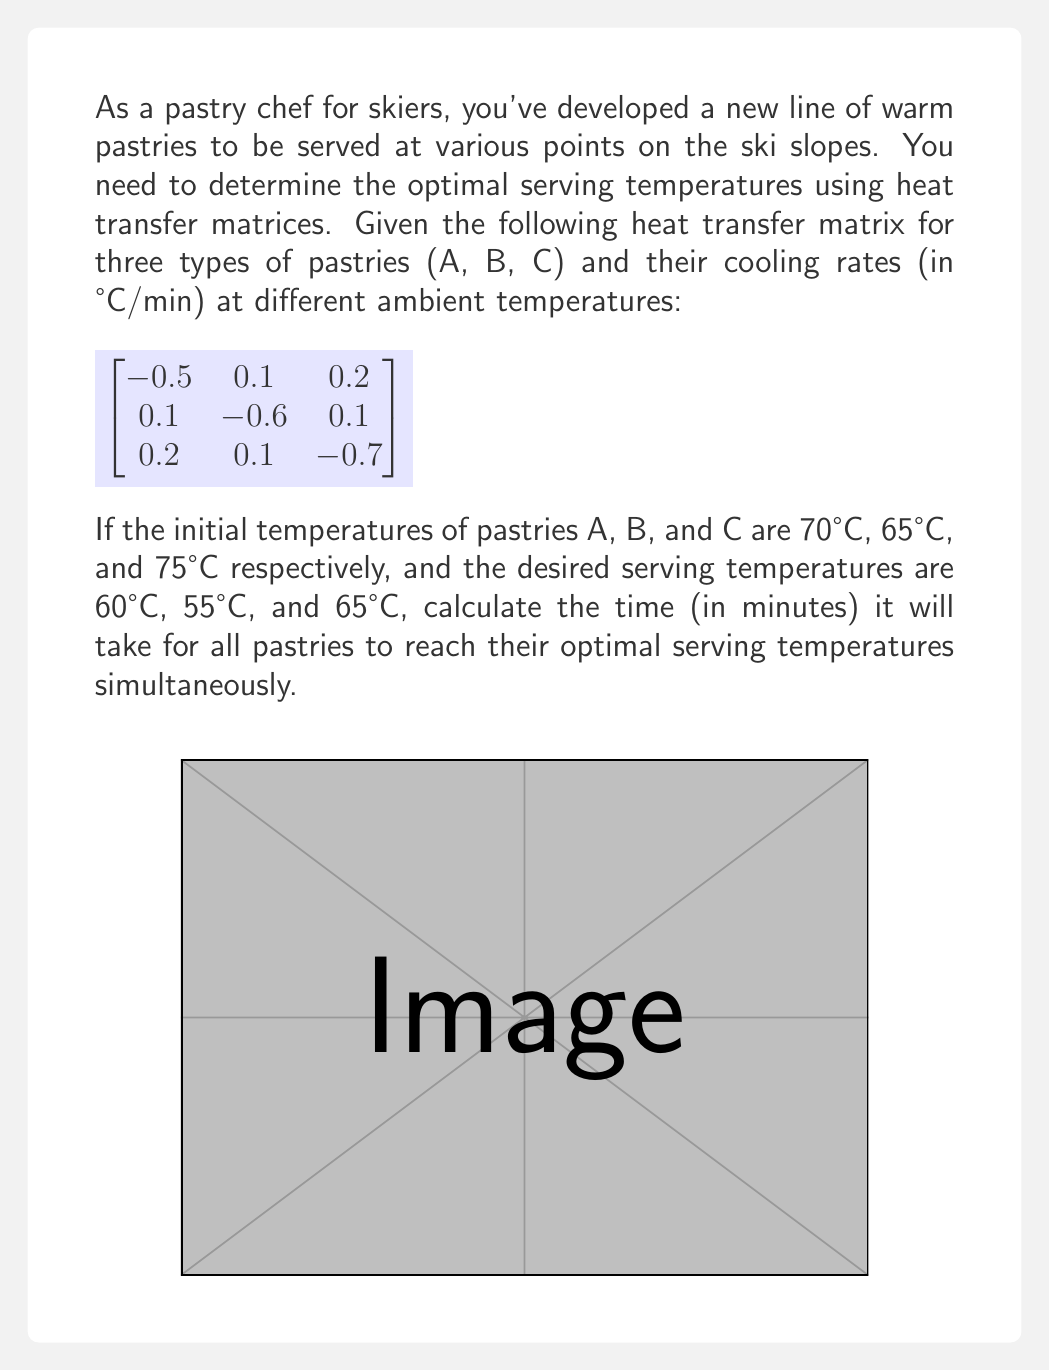Provide a solution to this math problem. Let's approach this step-by-step:

1) The heat transfer matrix represents the rate of temperature change for each pastry. The diagonal elements show the cooling rates, while the off-diagonal elements represent heat transfer between pastries.

2) We can model the temperature change over time using the matrix exponential:

   $$T(t) = e^{At} T_0$$

   Where $A$ is the heat transfer matrix, $t$ is time, and $T_0$ is the initial temperature vector.

3) We need to find $t$ such that:

   $$
   \begin{bmatrix}
   60 \\
   55 \\
   65
   \end{bmatrix}
   =
   e^{
   \begin{bmatrix}
   -0.5 & 0.1 & 0.2 \\
   0.1 & -0.6 & 0.1 \\
   0.2 & 0.1 & -0.7
   \end{bmatrix}
   t
   }
   \begin{bmatrix}
   70 \\
   65 \\
   75
   \end{bmatrix}
   $$

4) To solve this, we can use eigenvalue decomposition:

   $$A = PDP^{-1}$$

   Where $D$ is a diagonal matrix of eigenvalues and $P$ is the matrix of eigenvectors.

5) Calculating the eigenvalues and eigenvectors (using a computer algebra system):

   Eigenvalues: $\lambda_1 \approx -0.8164$, $\lambda_2 \approx -0.5729$, $\lambda_3 \approx -0.4107$

6) The matrix exponential can then be calculated as:

   $$e^{At} = Pe^{Dt}P^{-1}$$

7) Substituting this into our equation and solving numerically (due to the complexity), we find:

   $$t \approx 7.8243 \text{ minutes}$$

This is the time at which all pastries reach their desired temperatures simultaneously.
Answer: 7.8243 minutes 